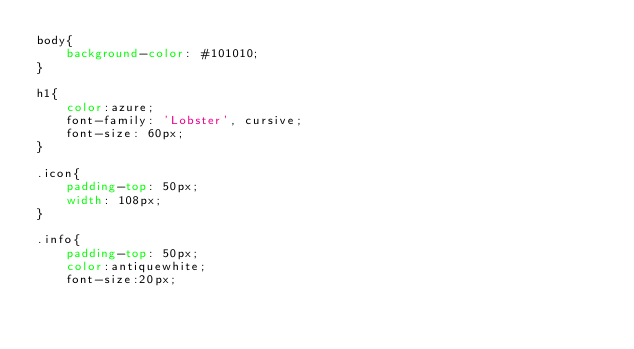Convert code to text. <code><loc_0><loc_0><loc_500><loc_500><_CSS_>body{
    background-color: #101010;
}

h1{
    color:azure;
    font-family: 'Lobster', cursive;
    font-size: 60px;
}

.icon{
    padding-top: 50px;
    width: 108px;
}

.info{
    padding-top: 50px;
    color:antiquewhite;
    font-size:20px;</code> 